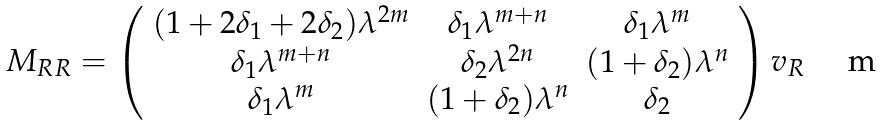Convert formula to latex. <formula><loc_0><loc_0><loc_500><loc_500>M _ { R R } = \left ( \begin{array} { c c c } ( 1 + 2 \delta _ { 1 } + 2 \delta _ { 2 } ) \lambda ^ { 2 m } & \delta _ { 1 } \lambda ^ { m + n } & \delta _ { 1 } \lambda ^ { m } \\ \delta _ { 1 } \lambda ^ { m + n } & \delta _ { 2 } \lambda ^ { 2 n } & ( 1 + \delta _ { 2 } ) \lambda ^ { n } \\ \delta _ { 1 } \lambda ^ { m } & ( 1 + \delta _ { 2 } ) \lambda ^ { n } & \delta _ { 2 } \end{array} \right ) v _ { R }</formula> 